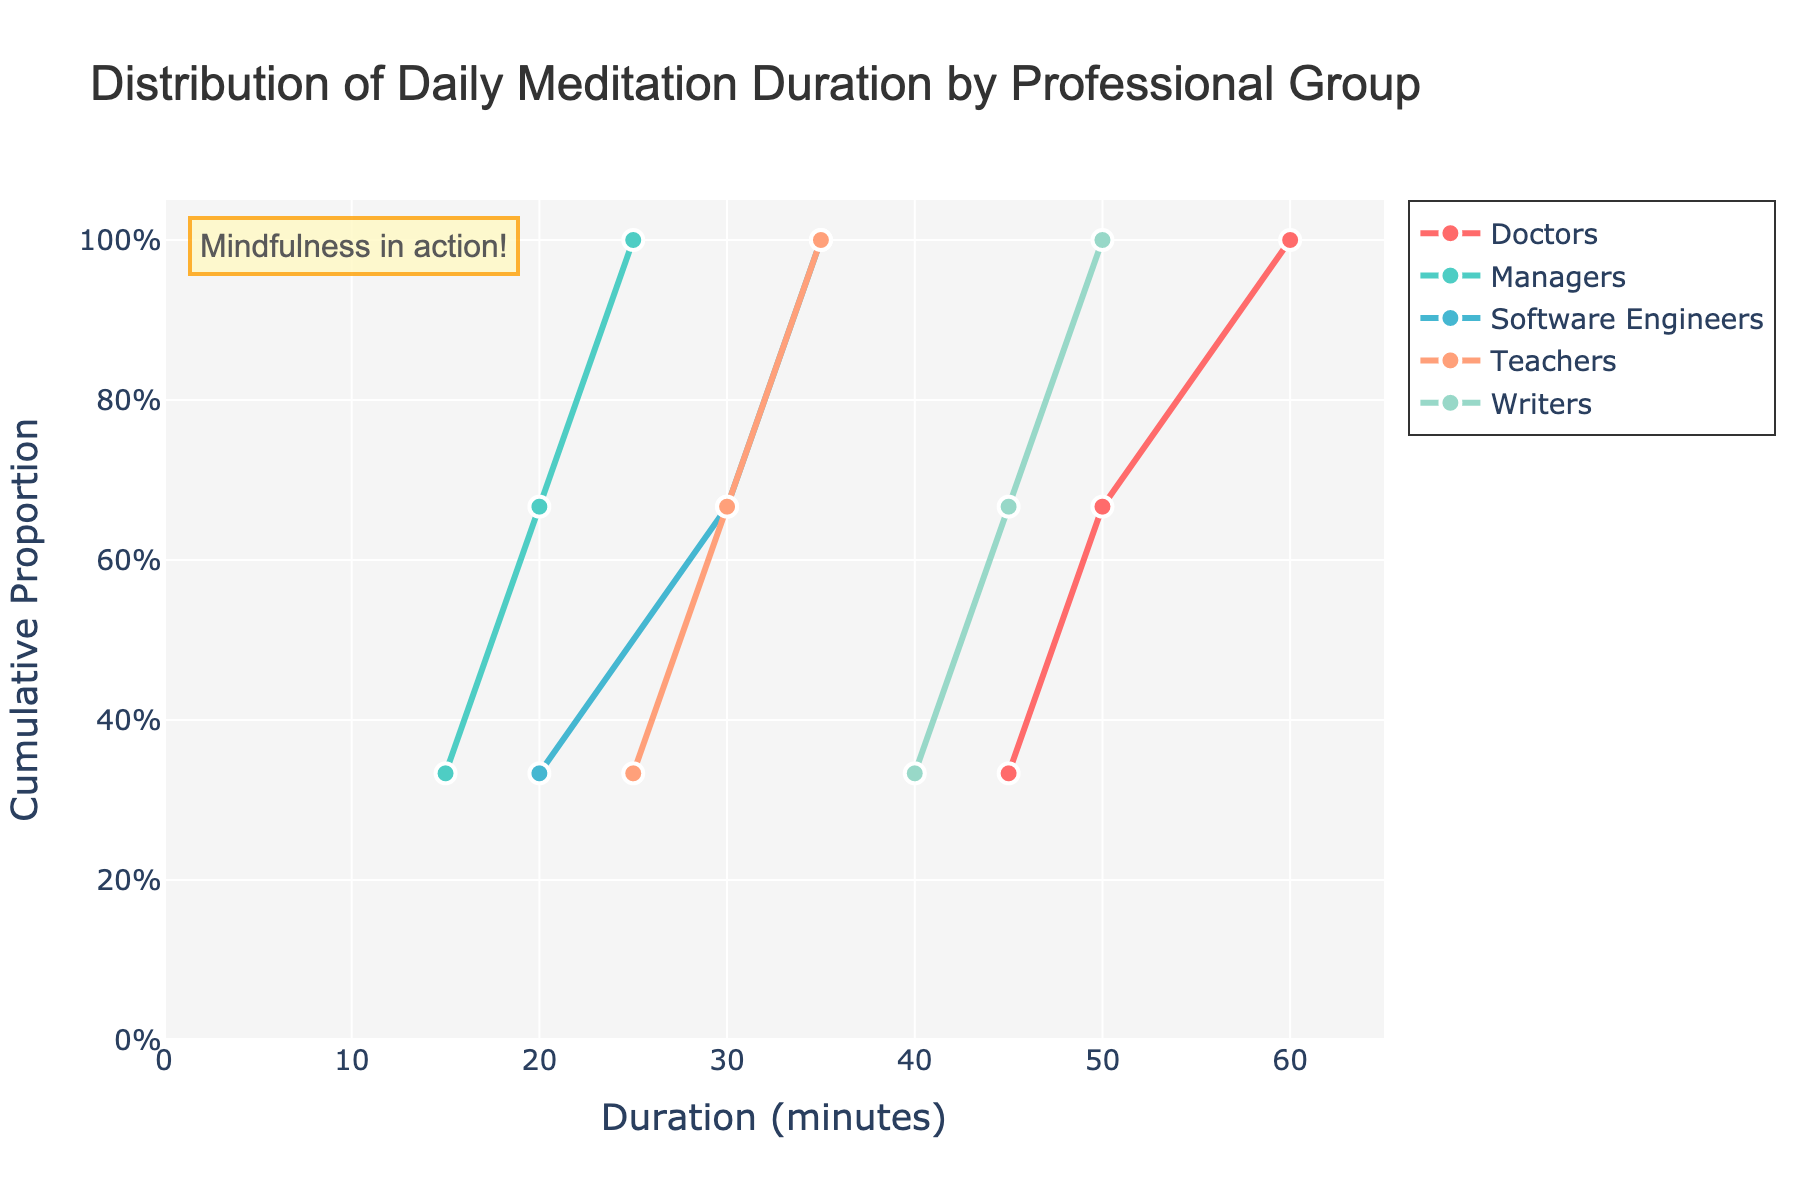What is the title of the figure? The title is usually placed at the top of the figure. It provides a summary of what the figure represents.
Answer: Distribution of Daily Meditation Duration by Professional Group How many professional groups are represented in the figure? The legend or the different colored lines can help identify the number of professional groups shown.
Answer: Five Which professional group has the highest maximum meditation duration? Look at the furthest point on the right for each group's line. The group associated with the furthest point will have the highest maximum.
Answer: Doctors What is the range of meditation duration for Teachers? Identify the minimum and maximum value on the x-axis for the "Teachers" line. Subtract the minimum duration from the maximum duration.
Answer: 25-35 minutes What proportion of Managers meditate for 20 minutes or less? Locate the "Managers" line and find the corresponding y-value when the x-value is 20 minutes. This y-value represents the proportion.
Answer: 2/3 or approximately 66.7% Which group has the most consistent meditation duration? The most consistent group will have the shortest range in duration values, resulting in a steeper or more vertical line.
Answer: Software Engineers At what duration do half of the Doctors meditate? Find the median duration for Doctors. Locate the 0.5 (50%) mark on the y-axis and trace horizontally to the Doctors' line, then trace down to the x-axis.
Answer: 50 minutes Compare the median meditation durations between Writers and Managers. Which is higher? Identify the medians (50% point on y-axis) for both groups and compare their corresponding x-values.
Answer: Writers Which group has the widest spread in their meditation durations? Look for the group with the broadest range of x-values, indicating the widest spread.
Answer: Doctors What is the primary color used for the Teachers' line? Look at the legend or the line representing Teachers and note its color.
Answer: Light Green (color='#4ECDC4') 